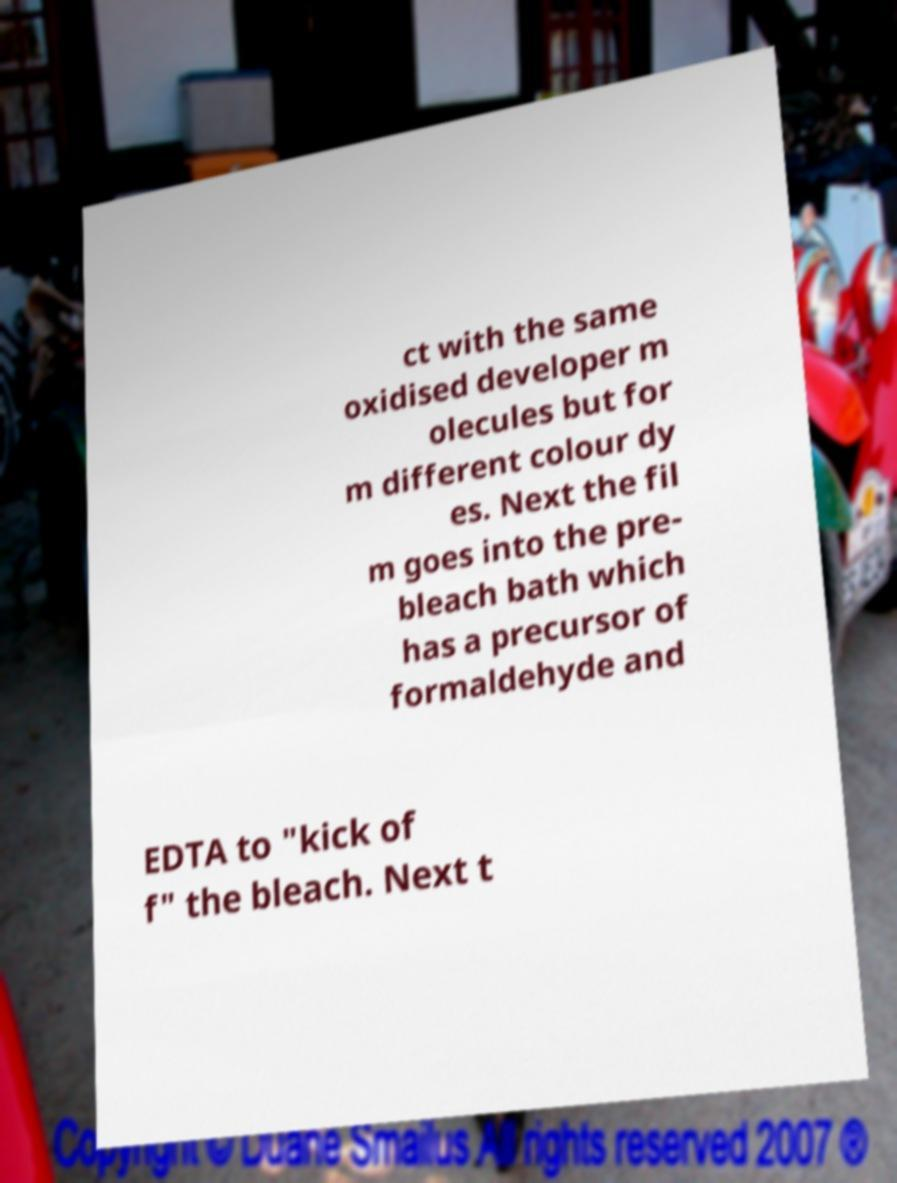What messages or text are displayed in this image? I need them in a readable, typed format. ct with the same oxidised developer m olecules but for m different colour dy es. Next the fil m goes into the pre- bleach bath which has a precursor of formaldehyde and EDTA to "kick of f" the bleach. Next t 